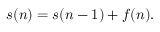<formula> <loc_0><loc_0><loc_500><loc_500>s ( n ) = s ( n - 1 ) + f ( n ) .</formula> 